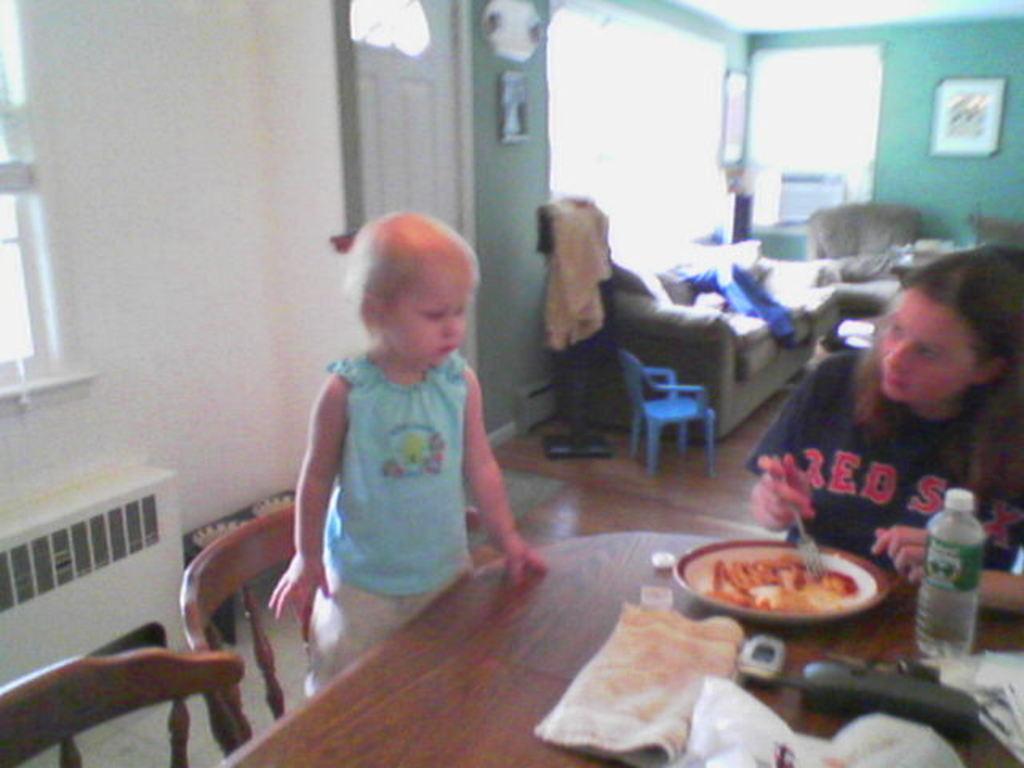Please provide a concise description of this image. This picture is clicked inside the room. On the right corner there is a person wearing t-shirt, holding a fork and sitting on the chair and we can see a water bottle, platter containing food item, napkin and some other items are placed on the top of the wooden table. On the left there is a kid wearing blue color t-shirt and standing on the wooden chair. On the left corner we can see a wooden chair and some other objects are placed on the ground. In the background we can see a picture frame hanging on the wall and we can see the door and windows and we can see a blue color chair and we can see the sofas and many other objects 